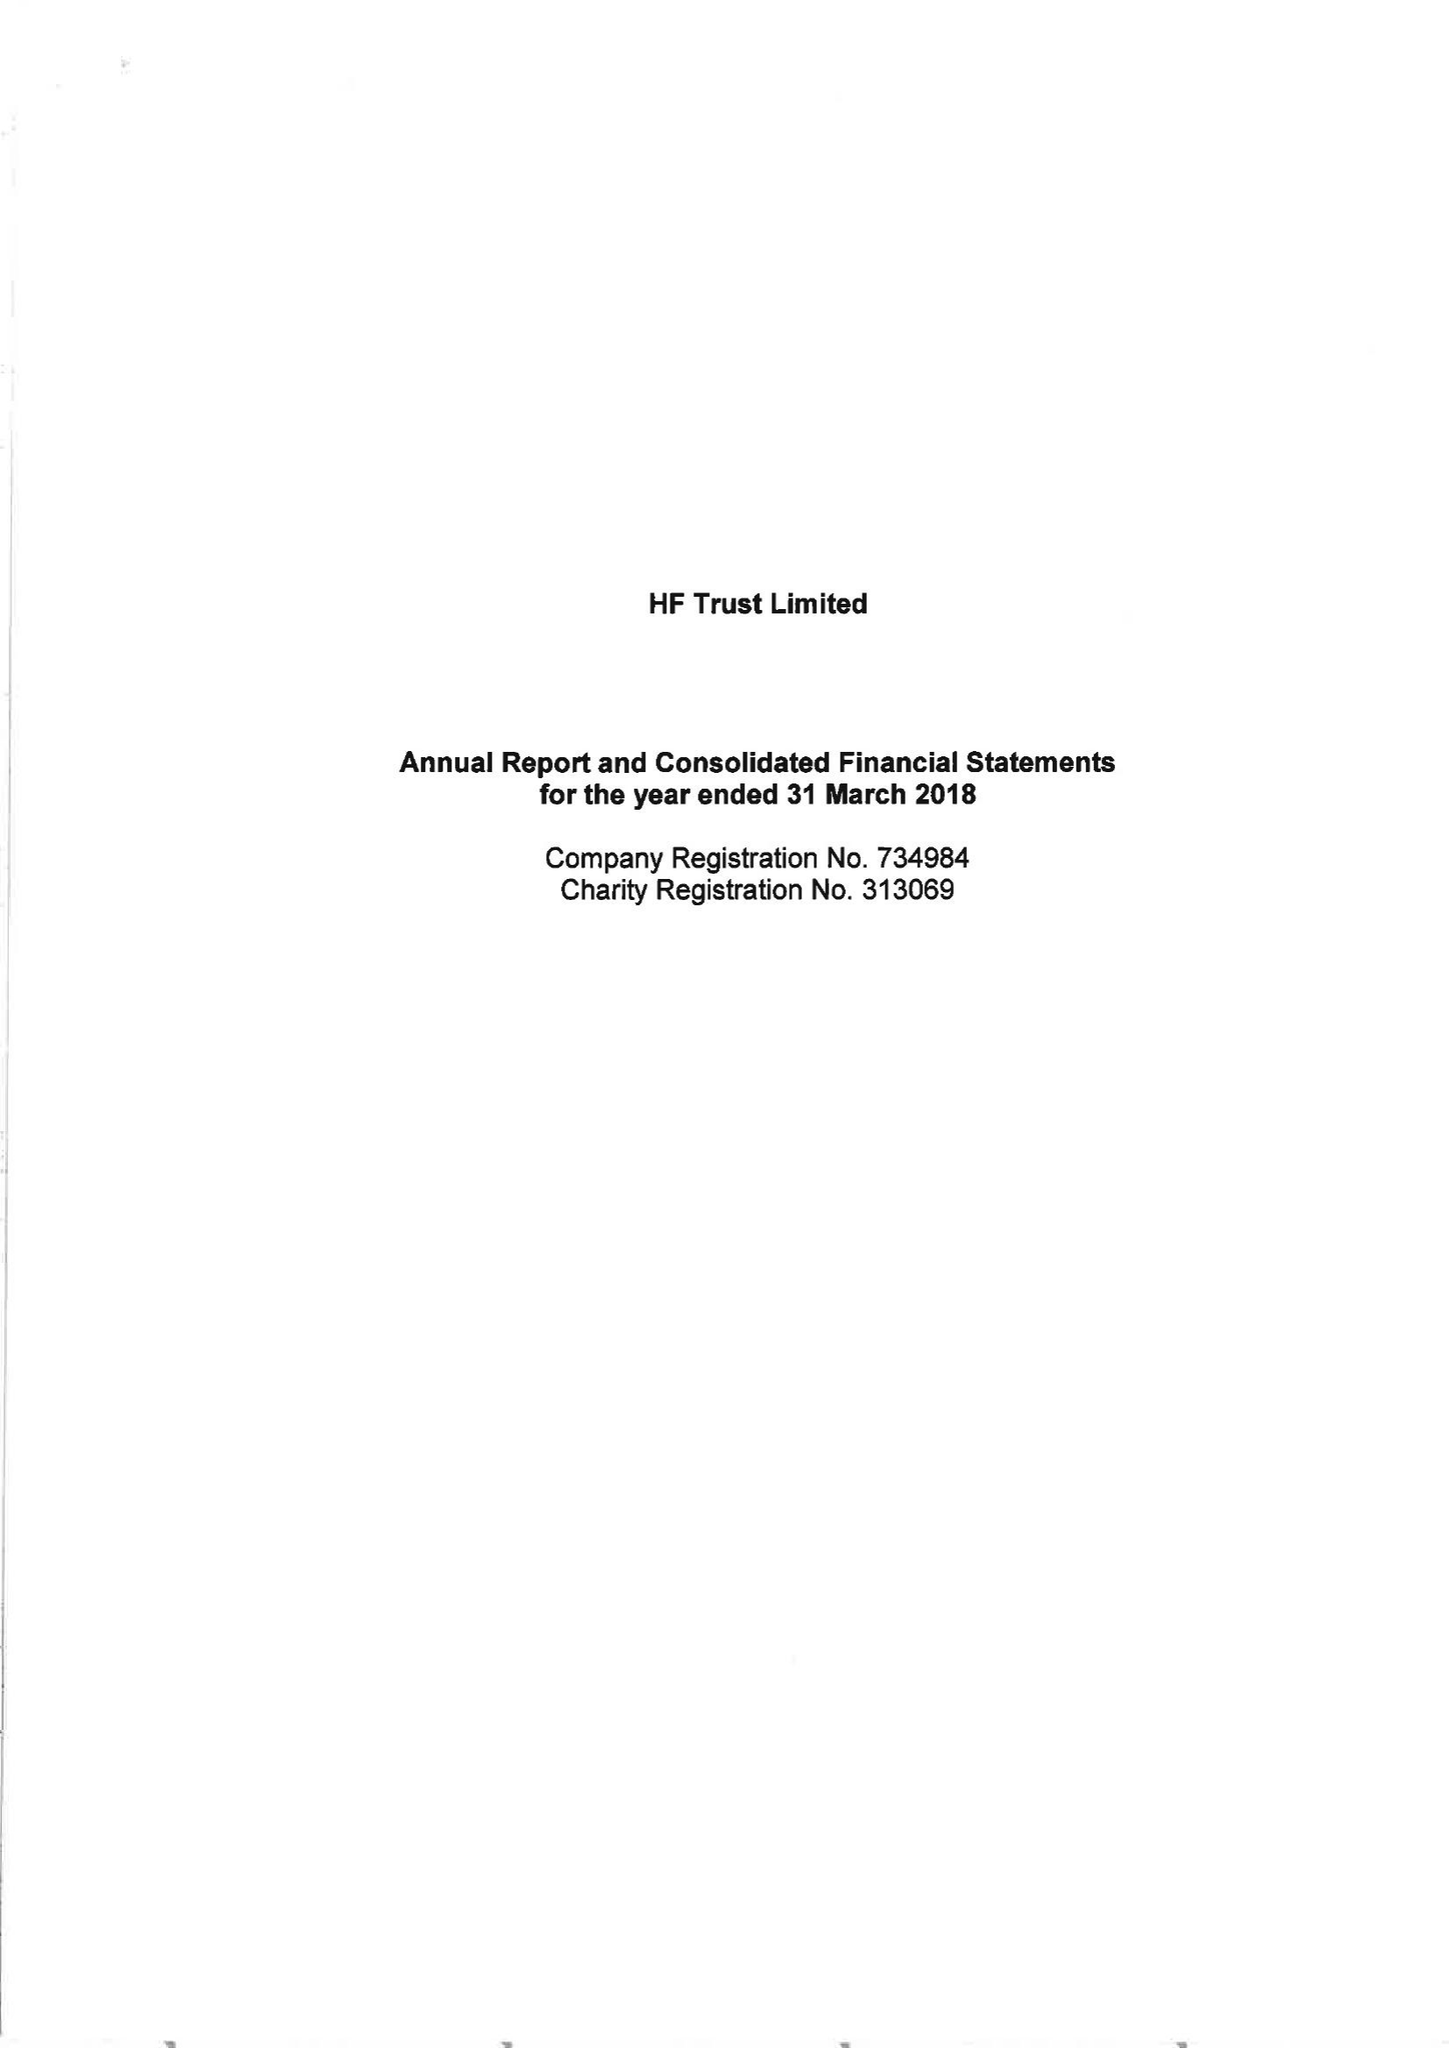What is the value for the income_annually_in_british_pounds?
Answer the question using a single word or phrase. 85018000.00 